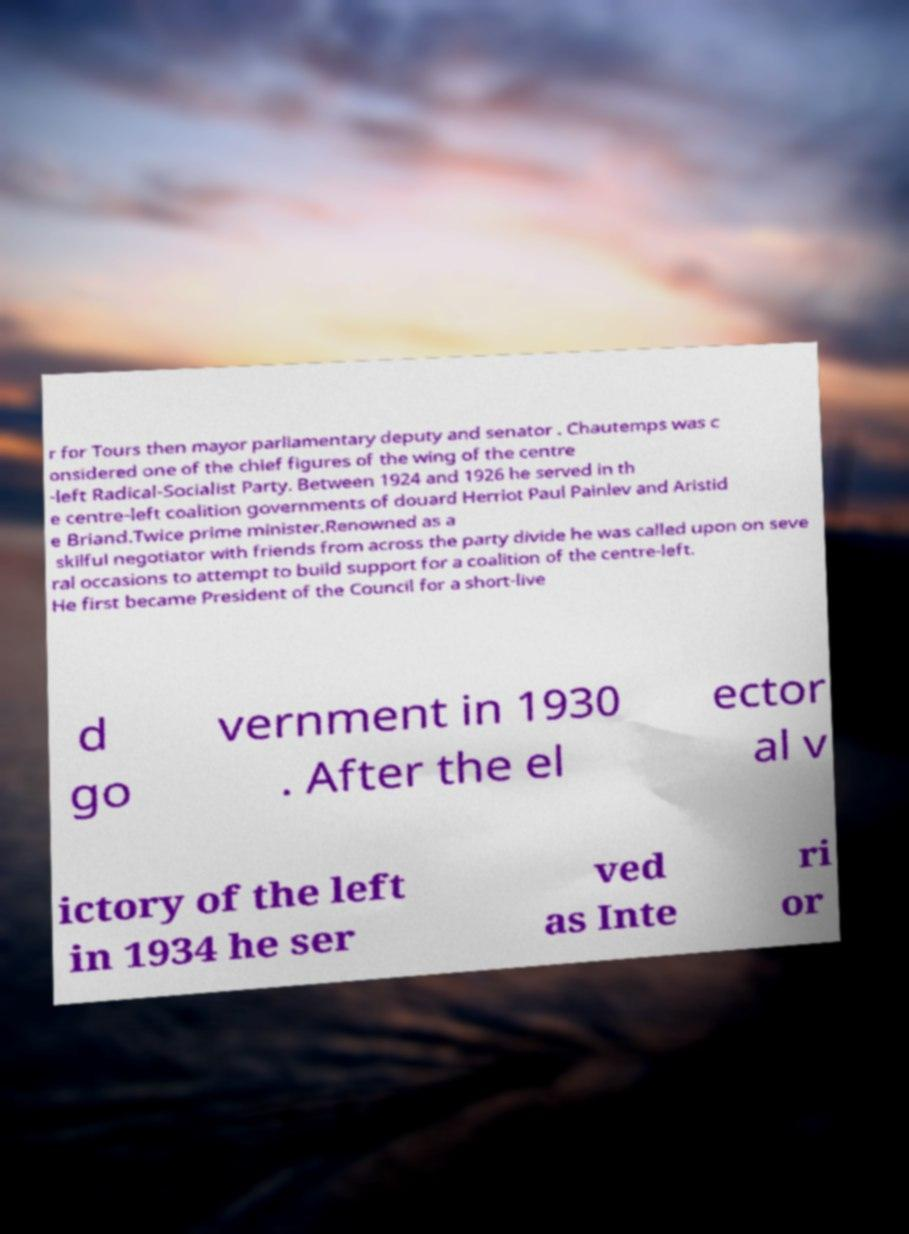Please identify and transcribe the text found in this image. r for Tours then mayor parliamentary deputy and senator . Chautemps was c onsidered one of the chief figures of the wing of the centre -left Radical-Socialist Party. Between 1924 and 1926 he served in th e centre-left coalition governments of douard Herriot Paul Painlev and Aristid e Briand.Twice prime minister.Renowned as a skilful negotiator with friends from across the party divide he was called upon on seve ral occasions to attempt to build support for a coalition of the centre-left. He first became President of the Council for a short-live d go vernment in 1930 . After the el ector al v ictory of the left in 1934 he ser ved as Inte ri or 